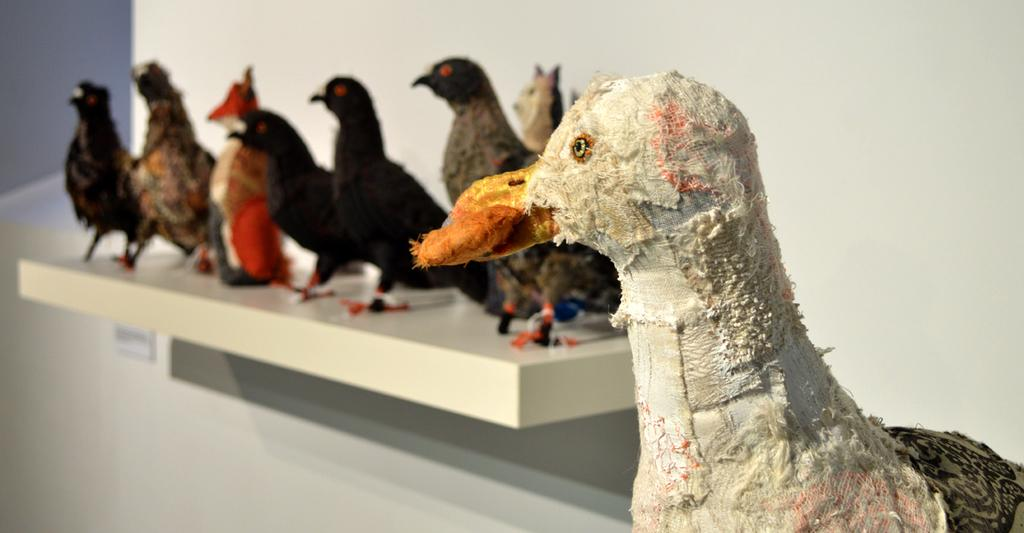What type of statues can be seen in the image? There are statues of birds in the image. What is visible in the background of the image? There is a wall in the background of the image. How many turkeys are present in the image? There are no turkeys present in the image; it features statues of birds. What type of request can be made to the statues in the image? The statues in the image are not capable of receiving or fulfilling requests, as they are inanimate objects. 